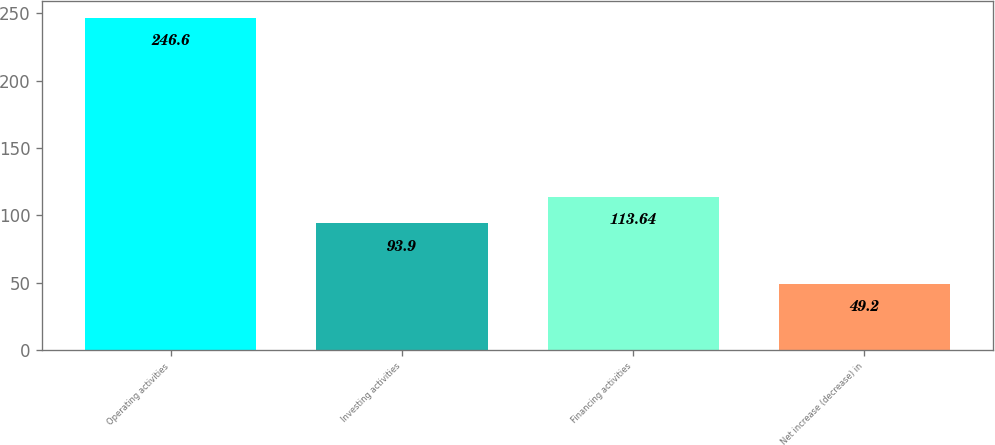Convert chart to OTSL. <chart><loc_0><loc_0><loc_500><loc_500><bar_chart><fcel>Operating activities<fcel>Investing activities<fcel>Financing activities<fcel>Net increase (decrease) in<nl><fcel>246.6<fcel>93.9<fcel>113.64<fcel>49.2<nl></chart> 